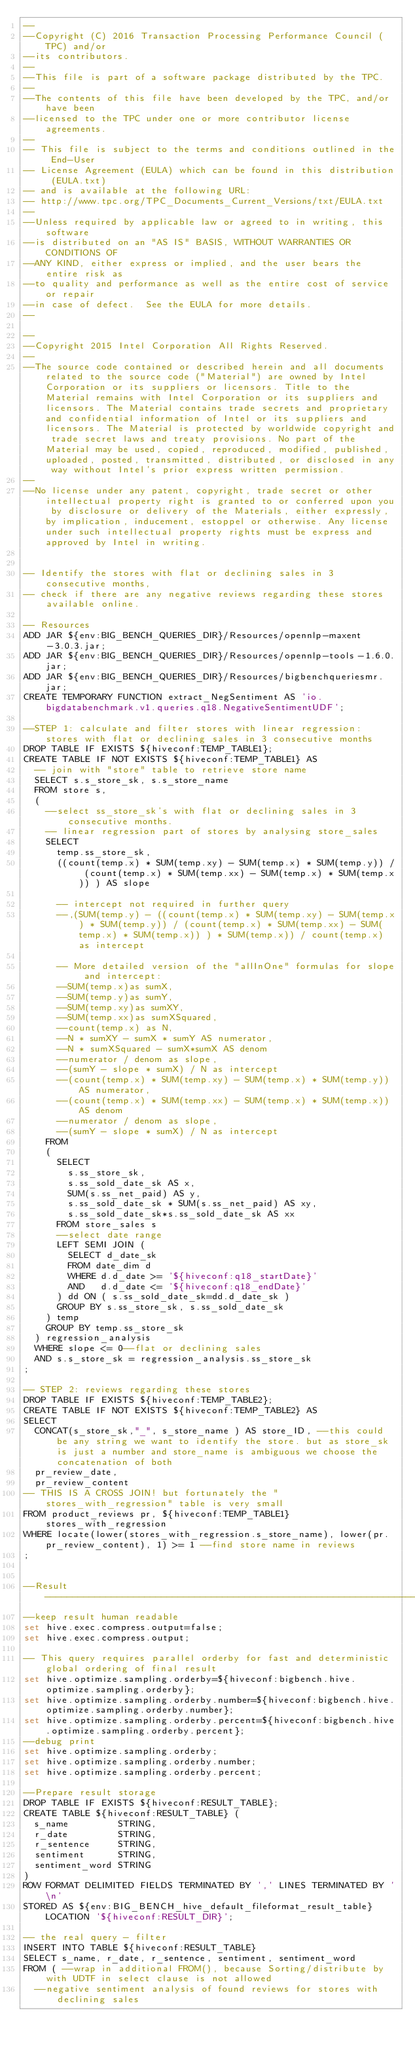Convert code to text. <code><loc_0><loc_0><loc_500><loc_500><_SQL_>--
--Copyright (C) 2016 Transaction Processing Performance Council (TPC) and/or
--its contributors.
--
--This file is part of a software package distributed by the TPC.
--
--The contents of this file have been developed by the TPC, and/or have been
--licensed to the TPC under one or more contributor license agreements.
--
-- This file is subject to the terms and conditions outlined in the End-User
-- License Agreement (EULA) which can be found in this distribution (EULA.txt)
-- and is available at the following URL:
-- http://www.tpc.org/TPC_Documents_Current_Versions/txt/EULA.txt
--
--Unless required by applicable law or agreed to in writing, this software
--is distributed on an "AS IS" BASIS, WITHOUT WARRANTIES OR CONDITIONS OF
--ANY KIND, either express or implied, and the user bears the entire risk as
--to quality and performance as well as the entire cost of service or repair
--in case of defect.  See the EULA for more details.
--

--
--Copyright 2015 Intel Corporation All Rights Reserved.
--
--The source code contained or described herein and all documents related to the source code ("Material") are owned by Intel Corporation or its suppliers or licensors. Title to the Material remains with Intel Corporation or its suppliers and licensors. The Material contains trade secrets and proprietary and confidential information of Intel or its suppliers and licensors. The Material is protected by worldwide copyright and trade secret laws and treaty provisions. No part of the Material may be used, copied, reproduced, modified, published, uploaded, posted, transmitted, distributed, or disclosed in any way without Intel's prior express written permission.
--
--No license under any patent, copyright, trade secret or other intellectual property right is granted to or conferred upon you by disclosure or delivery of the Materials, either expressly, by implication, inducement, estoppel or otherwise. Any license under such intellectual property rights must be express and approved by Intel in writing.


-- Identify the stores with flat or declining sales in 3 consecutive months,
-- check if there are any negative reviews regarding these stores available online.

-- Resources
ADD JAR ${env:BIG_BENCH_QUERIES_DIR}/Resources/opennlp-maxent-3.0.3.jar;
ADD JAR ${env:BIG_BENCH_QUERIES_DIR}/Resources/opennlp-tools-1.6.0.jar;
ADD JAR ${env:BIG_BENCH_QUERIES_DIR}/Resources/bigbenchqueriesmr.jar;
CREATE TEMPORARY FUNCTION extract_NegSentiment AS 'io.bigdatabenchmark.v1.queries.q18.NegativeSentimentUDF';

--STEP 1: calculate and filter stores with linear regression: stores with flat or declining sales in 3 consecutive months
DROP TABLE IF EXISTS ${hiveconf:TEMP_TABLE1};
CREATE TABLE IF NOT EXISTS ${hiveconf:TEMP_TABLE1} AS
  -- join with "store" table to retrieve store name
  SELECT s.s_store_sk, s.s_store_name
  FROM store s,
  (
    --select ss_store_sk's with flat or declining sales in 3 consecutive months.
    -- linear regression part of stores by analysing store_sales
    SELECT
      temp.ss_store_sk,
      ((count(temp.x) * SUM(temp.xy) - SUM(temp.x) * SUM(temp.y)) / (count(temp.x) * SUM(temp.xx) - SUM(temp.x) * SUM(temp.x)) ) AS slope

      -- intercept not required in further query
      --,(SUM(temp.y) - ((count(temp.x) * SUM(temp.xy) - SUM(temp.x) * SUM(temp.y)) / (count(temp.x) * SUM(temp.xx) - SUM(temp.x) * SUM(temp.x)) ) * SUM(temp.x)) / count(temp.x) as intercept

      -- More detailed version of the "allInOne" formulas for slope and intercept:
      --SUM(temp.x)as sumX,
      --SUM(temp.y)as sumY,
      --SUM(temp.xy)as sumXY,
      --SUM(temp.xx)as sumXSquared,
      --count(temp.x) as N,
      --N * sumXY - sumX * sumY AS numerator,
      --N * sumXSquared - sumX*sumX AS denom
      --numerator / denom as slope,
      --(sumY - slope * sumX) / N as intercept
      --(count(temp.x) * SUM(temp.xy) - SUM(temp.x) * SUM(temp.y)) AS numerator,
      --(count(temp.x) * SUM(temp.xx) - SUM(temp.x) * SUM(temp.x)) AS denom
      --numerator / denom as slope,
      --(sumY - slope * sumX) / N as intercept
    FROM
    (
      SELECT
        s.ss_store_sk,
        s.ss_sold_date_sk AS x,
        SUM(s.ss_net_paid) AS y,
        s.ss_sold_date_sk * SUM(s.ss_net_paid) AS xy,
        s.ss_sold_date_sk*s.ss_sold_date_sk AS xx
      FROM store_sales s
      --select date range
      LEFT SEMI JOIN (
        SELECT d_date_sk
        FROM date_dim d
        WHERE d.d_date >= '${hiveconf:q18_startDate}'
        AND   d.d_date <= '${hiveconf:q18_endDate}'
      ) dd ON ( s.ss_sold_date_sk=dd.d_date_sk )
      GROUP BY s.ss_store_sk, s.ss_sold_date_sk
    ) temp
    GROUP BY temp.ss_store_sk
  ) regression_analysis
  WHERE slope <= 0--flat or declining sales
  AND s.s_store_sk = regression_analysis.ss_store_sk
;

-- STEP 2: reviews regarding these stores
DROP TABLE IF EXISTS ${hiveconf:TEMP_TABLE2};
CREATE TABLE IF NOT EXISTS ${hiveconf:TEMP_TABLE2} AS
SELECT
  CONCAT(s_store_sk,"_", s_store_name ) AS store_ID, --this could be any string we want to identify the store. but as store_sk is just a number and store_name is ambiguous we choose the concatenation of both
  pr_review_date,
  pr_review_content
-- THIS IS A CROSS JOIN! but fortunately the "stores_with_regression" table is very small
FROM product_reviews pr, ${hiveconf:TEMP_TABLE1} stores_with_regression
WHERE locate(lower(stores_with_regression.s_store_name), lower(pr.pr_review_content), 1) >= 1 --find store name in reviews
;


--Result  --------------------------------------------------------------------
--keep result human readable
set hive.exec.compress.output=false;
set hive.exec.compress.output;

-- This query requires parallel orderby for fast and deterministic global ordering of final result
set hive.optimize.sampling.orderby=${hiveconf:bigbench.hive.optimize.sampling.orderby};
set hive.optimize.sampling.orderby.number=${hiveconf:bigbench.hive.optimize.sampling.orderby.number};
set hive.optimize.sampling.orderby.percent=${hiveconf:bigbench.hive.optimize.sampling.orderby.percent};
--debug print
set hive.optimize.sampling.orderby;
set hive.optimize.sampling.orderby.number;
set hive.optimize.sampling.orderby.percent;

--Prepare result storage
DROP TABLE IF EXISTS ${hiveconf:RESULT_TABLE};
CREATE TABLE ${hiveconf:RESULT_TABLE} (
  s_name         STRING,
  r_date         STRING,
  r_sentence     STRING,
  sentiment      STRING,
  sentiment_word STRING
)
ROW FORMAT DELIMITED FIELDS TERMINATED BY ',' LINES TERMINATED BY '\n'
STORED AS ${env:BIG_BENCH_hive_default_fileformat_result_table} LOCATION '${hiveconf:RESULT_DIR}';

-- the real query - filter
INSERT INTO TABLE ${hiveconf:RESULT_TABLE}
SELECT s_name, r_date, r_sentence, sentiment, sentiment_word
FROM ( --wrap in additional FROM(), because Sorting/distribute by with UDTF in select clause is not allowed
  --negative sentiment analysis of found reviews for stores with declining sales</code> 